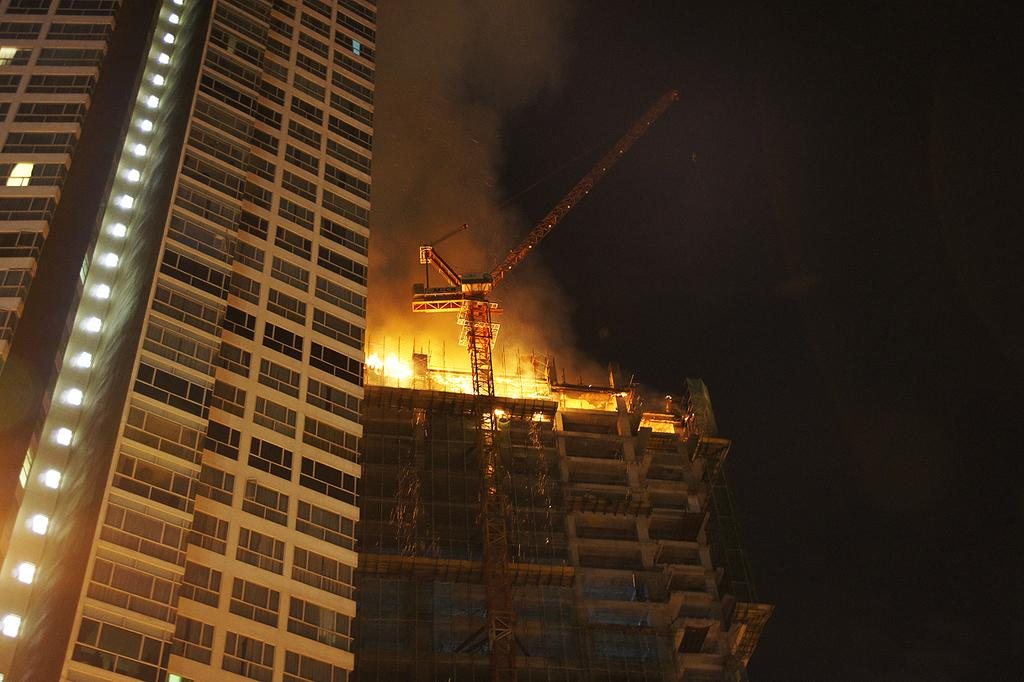How many buildings can be seen in the image? There are two buildings in the image. What is happening to one of the buildings? There is a fire in one of the buildings. What can be seen in the background of the image? The sky is visible in the background of the image. Where is the jar filled with netted dinosaurs in the image? There is no jar filled with netted dinosaurs present in the image. 